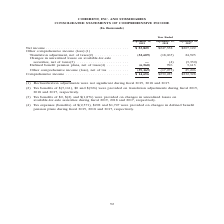According to Coherent's financial document, What was Net income in 2019? According to the financial document, $53,825 (in thousands). The relevant text states: "Net income . $ 53,825 $247,358 $207,122 Other comprehensive income (loss):(1) Translation adjustment, net of taxes(2) . (..." Also, What was  Comprehensive income  in 2018? According to the financial document, $230,285 (in thousands). The relevant text states: "Comprehensive income . $ 14,656 $230,285 $232,328..." Also, In which years was Comprehensive income calculated? The document contains multiple relevant values: 2019, 2018, 2017. From the document: "ptember 28, September 29, September 30, 2019 2018 2017 r Ended September 28, September 29, September 30, 2019 2018 2017 ed September 28, September 29,..." Additionally, In which year was Comprehensive income largest? According to the financial document, 2017. The relevant text states: "ptember 28, September 29, September 30, 2019 2018 2017..." Also, can you calculate: What was the change in Net income in 2018 from 2017? Based on the calculation: 247,358-207,122, the result is 40236 (in thousands). This is based on the information: "Net income . $ 53,825 $247,358 $207,122 Other comprehensive income (loss):(1) Translation adjustment, net of taxes(2) . (32,609) ( Net income . $ 53,825 $247,358 $207,122 Other comprehensive income (l..." The key data points involved are: 207,122, 247,358. Also, can you calculate: What was the percentage change in Net income in 2018 from 2017? To answer this question, I need to perform calculations using the financial data. The calculation is: (247,358-207,122)/207,122, which equals 19.43 (percentage). This is based on the information: "Net income . $ 53,825 $247,358 $207,122 Other comprehensive income (loss):(1) Translation adjustment, net of taxes(2) . (32,609) ( Net income . $ 53,825 $247,358 $207,122 Other comprehensive income (l..." The key data points involved are: 207,122, 247,358. 